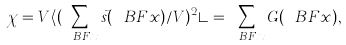Convert formula to latex. <formula><loc_0><loc_0><loc_500><loc_500>\chi = V \langle ( \sum _ { \ B F { x } } \vec { s } ( \ B F { x } ) / V ) ^ { 2 } \rangle = \sum _ { \ B F { x } } G ( \ B F { x } ) ,</formula> 